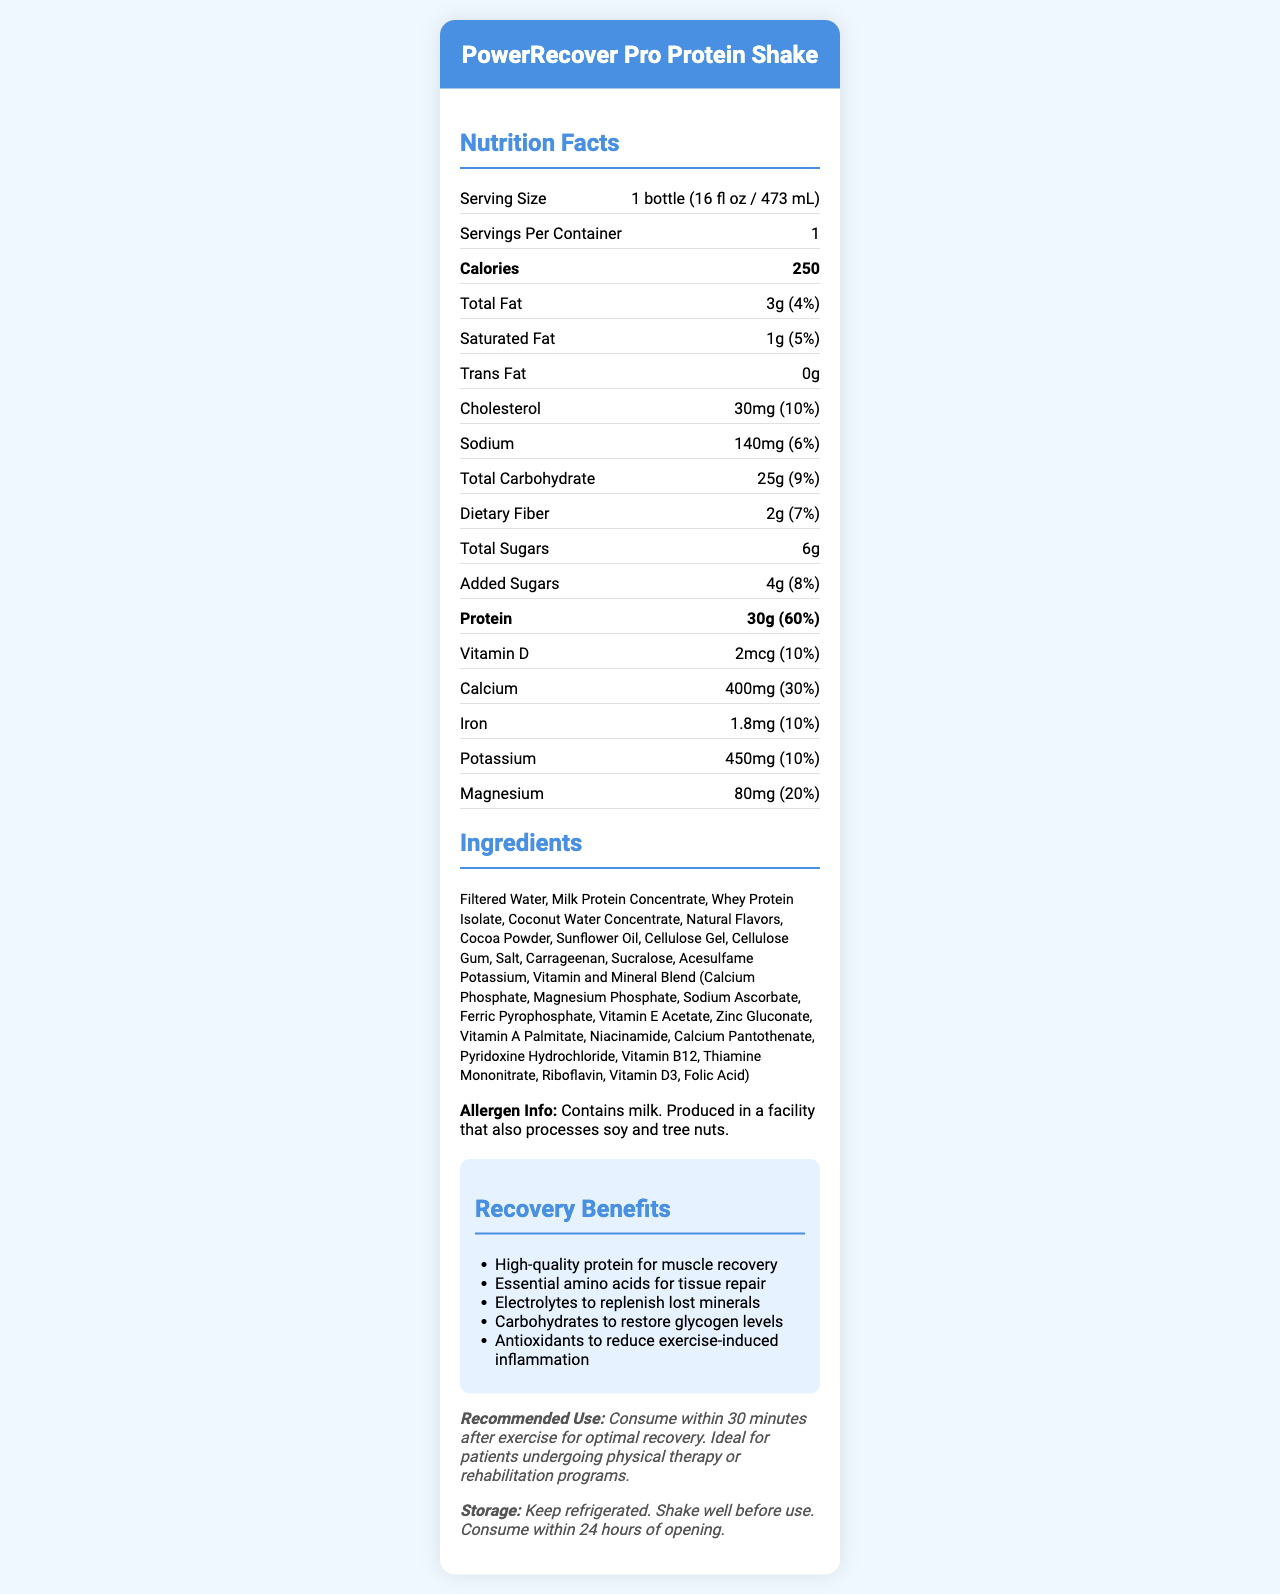what is the serving size? The serving size is stated clearly at the top of the Nutrition Facts section.
Answer: 1 bottle (16 fl oz / 473 mL) how many calories are in a serving? The calorie content is listed prominently in the Nutrition Facts section.
Answer: 250 how much protein does this shake contain? The protein amount is listed in the Nutrition Facts section, just below the calorie content.
Answer: 30g what is the daily value percentage for protein? The daily value percentage for protein is given right next to the protein amount in the Nutrition Facts section.
Answer: 60% which ingredient is listed first? Ingredients are listed in descending order by weight; Filtered Water is the first ingredient listed.
Answer: Filtered Water how many grams of total fat are in the shake? The amount of total fat is specified in the Nutrition Facts section.
Answer: 3g what percentage of the daily value for calcium does one serving provide? The daily value percentage for calcium is provided in the Nutrition Facts section.
Answer: 30% does this product contain any trans fat? The Nutrition Facts section indicates that the shake contains 0 grams of trans fat.
Answer: No how much added sugar is in this shake? The amount of added sugars is noted in the Nutrition Facts section under 'Total Sugars'.
Answer: 4g what are some of the recovery benefits of this shake? The recovery benefits are listed in a dedicated section under "Recovery Benefits".
Answer: High-quality protein for muscle recovery, Essential amino acids for tissue repair, Electrolytes to replenish lost minerals, Carbohydrates to restore glycogen levels, Antioxidants to reduce exercise-induced inflammation does this shake contain any allergens? The allergen information specifies that it contains milk and is produced in a facility that also processes soy and tree nuts.
Answer: Yes what is the best time to consume this shake for optimal recovery? The recommended use section advises consumption within 30 minutes after exercise.
Answer: Within 30 minutes after exercise how many milligrams of sodium does the shake contain? The sodium content is listed in the Nutrition Facts section.
Answer: 140mg is the product suitable for patients undergoing physical therapy? The recommended use section mentions that the product is ideal for patients undergoing physical therapy or rehabilitation programs.
Answer: Yes what is required before consuming the shake after opening? These instructions are given in the storage instructions section.
Answer: Shake well before use and consume within 24 hours of opening how much magnesium is in each serving of the shake? A. 60mg B. 70mg C. 80mg D. 90mg The amount of magnesium per serving is listed in the Nutrition Facts section.
Answer: C. 80mg how many grams of dietary fiber are in the shake? I. 1g II. 2g III. 3g IV. 4g The amount of dietary fiber is specified in the Nutrition Facts section.
Answer: II. 2g what amount of vitamin D does the shake provide? A. 1mcg B. 2mcg C. 3mcg D. 4mcg The amount of vitamin D is provided in the Nutrition Facts section.
Answer: B. 2mcg is this shake high in cholesterol? The shake contains 30mg of cholesterol, which is 10% of the daily value. This is not considered high cholesterol.
Answer: No describe the main idea of the document. The document's main idea revolves around giving comprehensive nutritional details and benefits of the PowerRecover Pro Protein Shake, emphasizing its use for recovery post-exercise.
Answer: The document provides detailed nutrition information, ingredients, allergen information, recovery benefits, and usage instructions for the PowerRecover Pro Protein Shake. The product is designed for post-workout recovery and is ideal for patients undergoing physical therapy or rehabilitation programs. what flavors are available? The document does not provide information on the available flavors of the shake.
Answer: Cannot be determined 